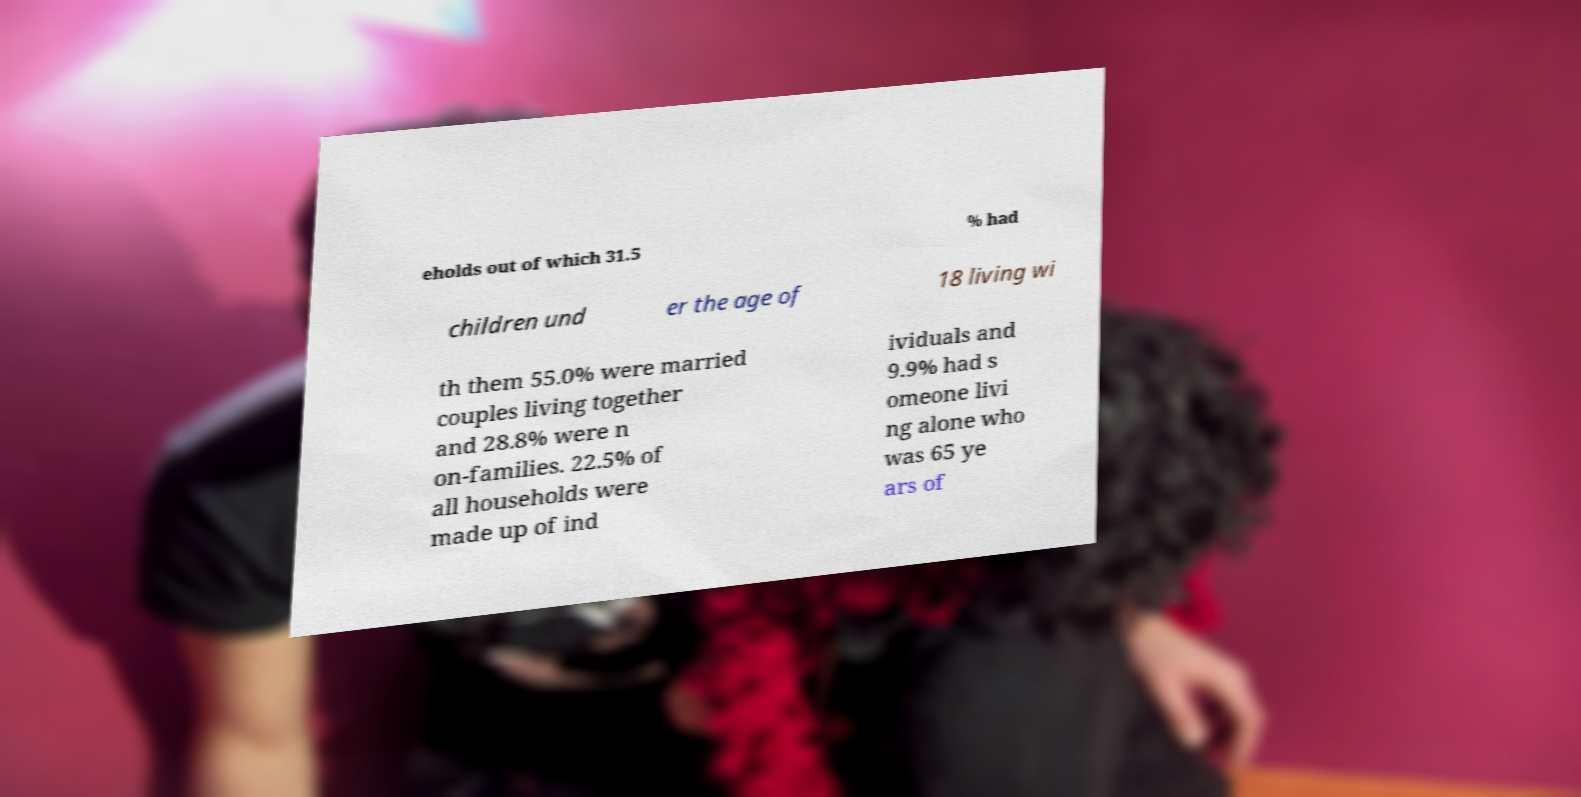Please identify and transcribe the text found in this image. eholds out of which 31.5 % had children und er the age of 18 living wi th them 55.0% were married couples living together and 28.8% were n on-families. 22.5% of all households were made up of ind ividuals and 9.9% had s omeone livi ng alone who was 65 ye ars of 